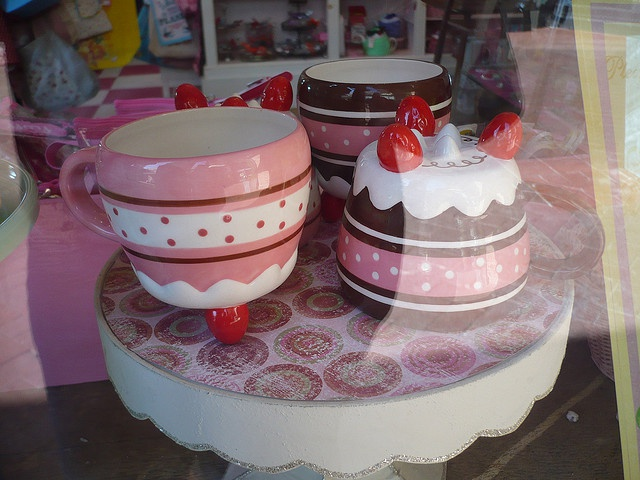Describe the objects in this image and their specific colors. I can see cup in black, darkgray, gray, lightpink, and purple tones and cup in black, gray, and maroon tones in this image. 